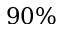<formula> <loc_0><loc_0><loc_500><loc_500>9 0 \%</formula> 